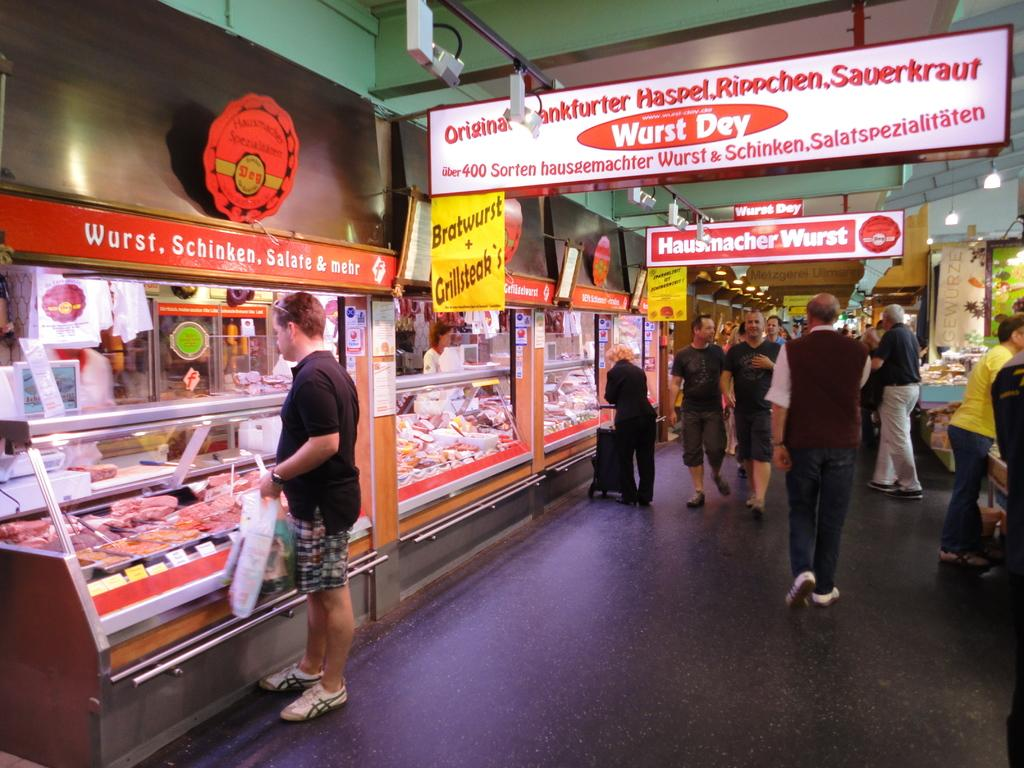<image>
Give a short and clear explanation of the subsequent image. A man is standing at a bratwurst counter in a food court. 